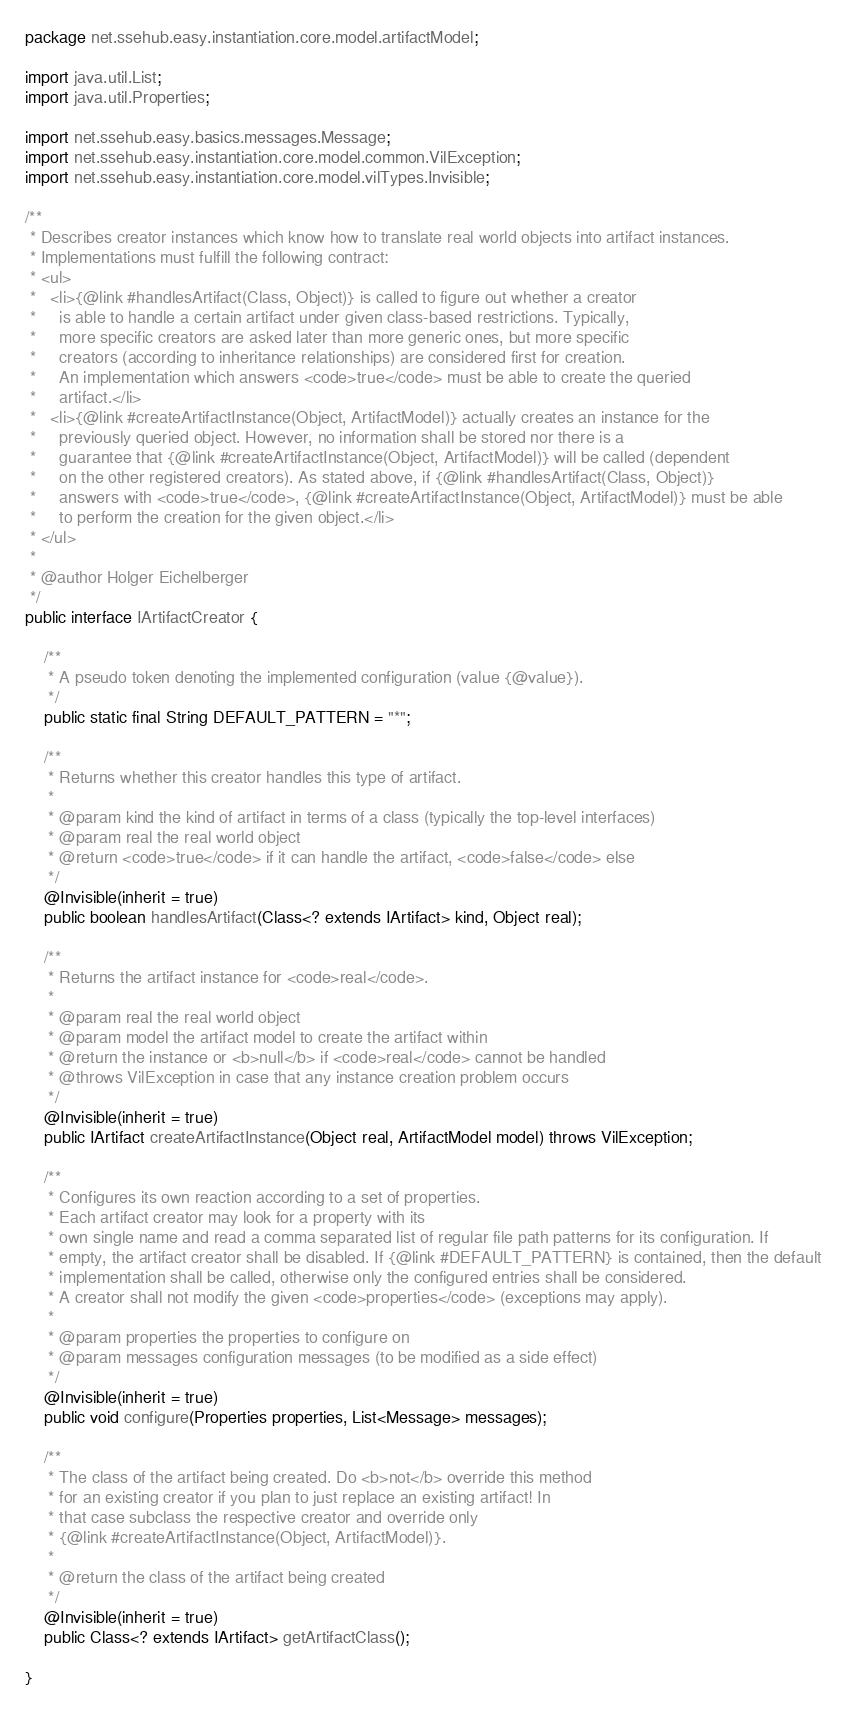Convert code to text. <code><loc_0><loc_0><loc_500><loc_500><_Java_>package net.ssehub.easy.instantiation.core.model.artifactModel;

import java.util.List;
import java.util.Properties;

import net.ssehub.easy.basics.messages.Message;
import net.ssehub.easy.instantiation.core.model.common.VilException;
import net.ssehub.easy.instantiation.core.model.vilTypes.Invisible;

/**
 * Describes creator instances which know how to translate real world objects into artifact instances.
 * Implementations must fulfill the following contract:
 * <ul>
 *   <li>{@link #handlesArtifact(Class, Object)} is called to figure out whether a creator
 *     is able to handle a certain artifact under given class-based restrictions. Typically, 
 *     more specific creators are asked later than more generic ones, but more specific
 *     creators (according to inheritance relationships) are considered first for creation.
 *     An implementation which answers <code>true</code> must be able to create the queried
 *     artifact.</li> 
 *   <li>{@link #createArtifactInstance(Object, ArtifactModel)} actually creates an instance for the 
 *     previously queried object. However, no information shall be stored nor there is a 
 *     guarantee that {@link #createArtifactInstance(Object, ArtifactModel)} will be called (dependent
 *     on the other registered creators). As stated above, if {@link #handlesArtifact(Class, Object)}
 *     answers with <code>true</code>, {@link #createArtifactInstance(Object, ArtifactModel)} must be able
 *     to perform the creation for the given object.</li>
 * </ul>
 * 
 * @author Holger Eichelberger
 */
public interface IArtifactCreator {

    /**
     * A pseudo token denoting the implemented configuration (value {@value}).
     */
    public static final String DEFAULT_PATTERN = "*";
    
    /**
     * Returns whether this creator handles this type of artifact.
     * 
     * @param kind the kind of artifact in terms of a class (typically the top-level interfaces)
     * @param real the real world object
     * @return <code>true</code> if it can handle the artifact, <code>false</code> else
     */
    @Invisible(inherit = true)
    public boolean handlesArtifact(Class<? extends IArtifact> kind, Object real);

    /**
     * Returns the artifact instance for <code>real</code>.
     * 
     * @param real the real world object
     * @param model the artifact model to create the artifact within
     * @return the instance or <b>null</b> if <code>real</code> cannot be handled
     * @throws VilException in case that any instance creation problem occurs
     */
    @Invisible(inherit = true)
    public IArtifact createArtifactInstance(Object real, ArtifactModel model) throws VilException;
    
    /**
     * Configures its own reaction according to a set of properties.
     * Each artifact creator may look for a property with its
     * own single name and read a comma separated list of regular file path patterns for its configuration. If
     * empty, the artifact creator shall be disabled. If {@link #DEFAULT_PATTERN} is contained, then the default
     * implementation shall be called, otherwise only the configured entries shall be considered.
     * A creator shall not modify the given <code>properties</code> (exceptions may apply).
     * 
     * @param properties the properties to configure on
     * @param messages configuration messages (to be modified as a side effect)
     */
    @Invisible(inherit = true)
    public void configure(Properties properties, List<Message> messages);
    
    /**
     * The class of the artifact being created. Do <b>not</b> override this method
     * for an existing creator if you plan to just replace an existing artifact! In
     * that case subclass the respective creator and override only 
     * {@link #createArtifactInstance(Object, ArtifactModel)}.
     * 
     * @return the class of the artifact being created
     */
    @Invisible(inherit = true)
    public Class<? extends IArtifact> getArtifactClass();

}
</code> 